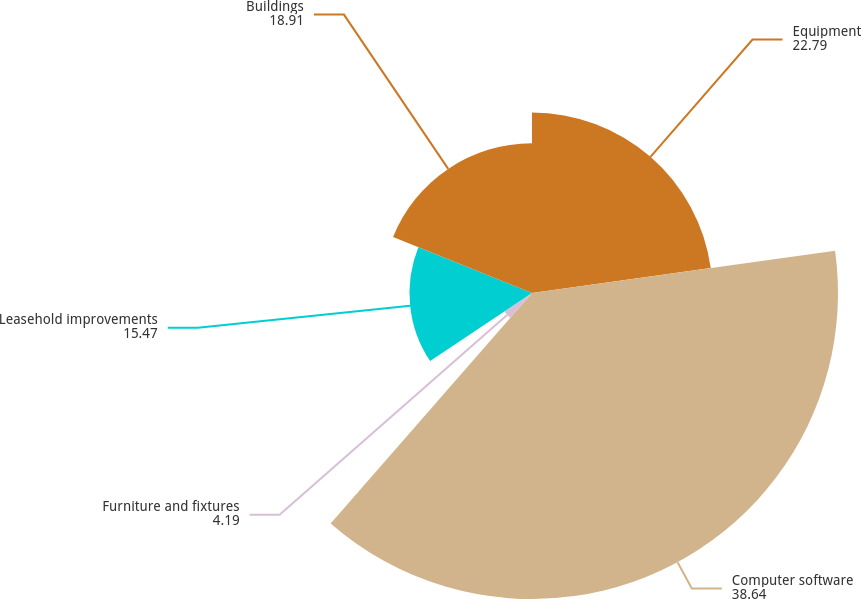Convert chart to OTSL. <chart><loc_0><loc_0><loc_500><loc_500><pie_chart><fcel>Equipment<fcel>Computer software<fcel>Furniture and fixtures<fcel>Leasehold improvements<fcel>Buildings<nl><fcel>22.79%<fcel>38.64%<fcel>4.19%<fcel>15.47%<fcel>18.91%<nl></chart> 